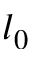<formula> <loc_0><loc_0><loc_500><loc_500>l _ { 0 }</formula> 